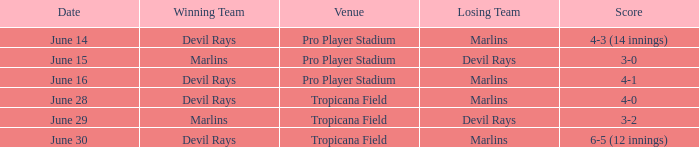What was the score of the game at pro player stadium on june 14? 4-3 (14 innings). 